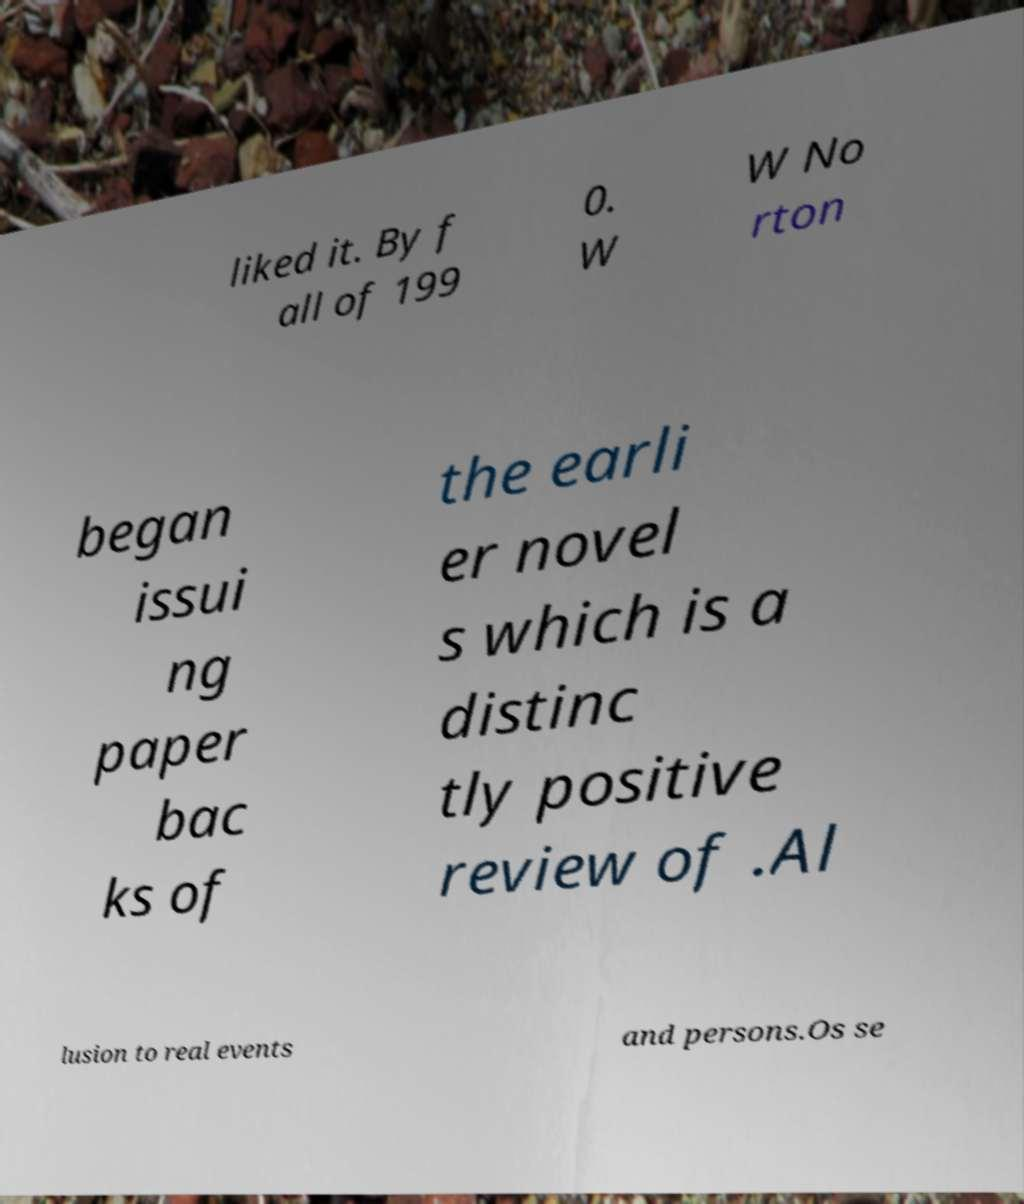There's text embedded in this image that I need extracted. Can you transcribe it verbatim? liked it. By f all of 199 0. W W No rton began issui ng paper bac ks of the earli er novel s which is a distinc tly positive review of .Al lusion to real events and persons.Os se 